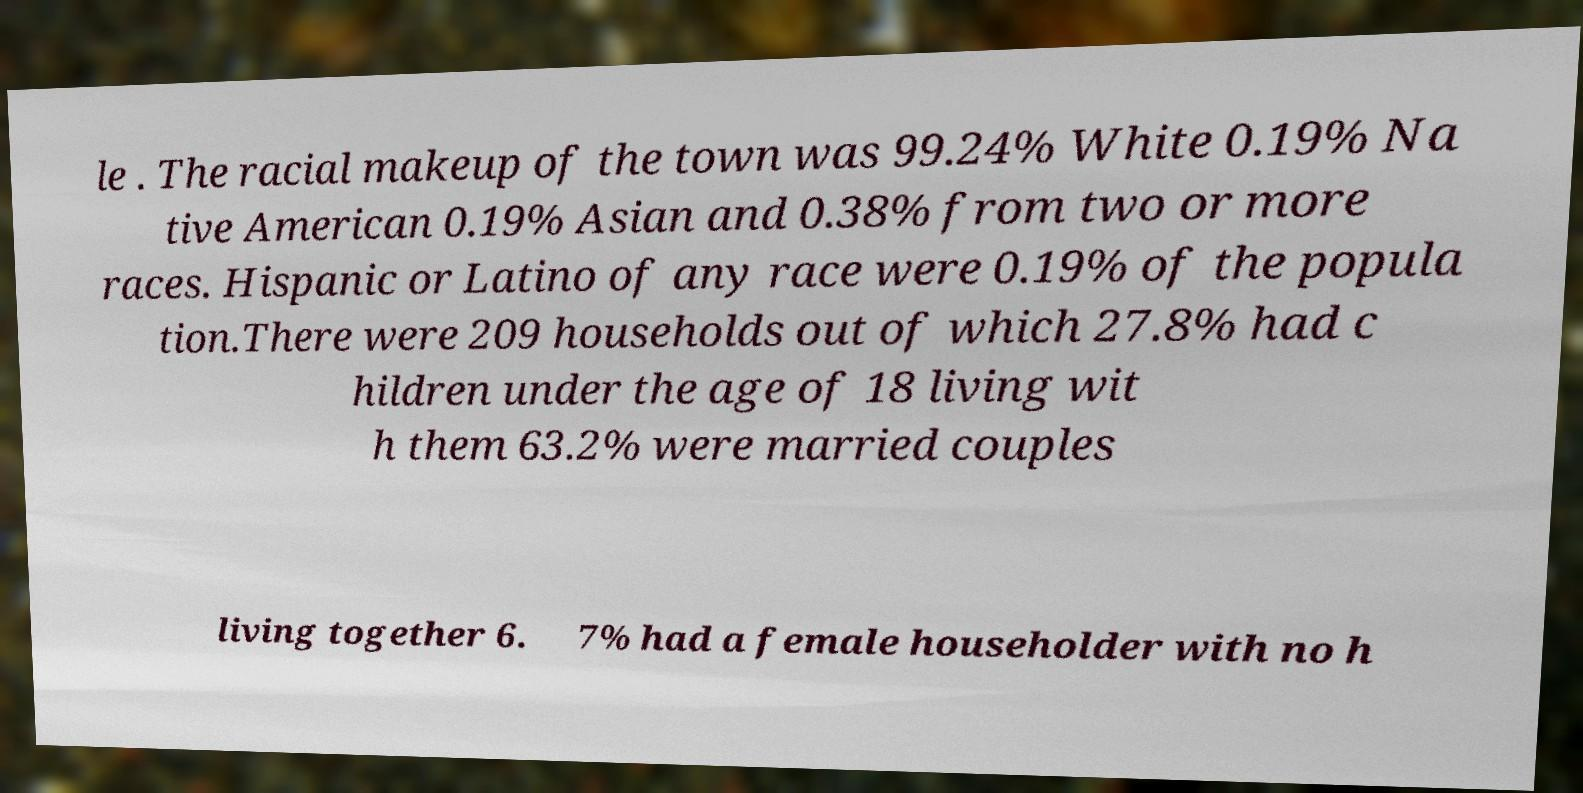Can you accurately transcribe the text from the provided image for me? le . The racial makeup of the town was 99.24% White 0.19% Na tive American 0.19% Asian and 0.38% from two or more races. Hispanic or Latino of any race were 0.19% of the popula tion.There were 209 households out of which 27.8% had c hildren under the age of 18 living wit h them 63.2% were married couples living together 6. 7% had a female householder with no h 